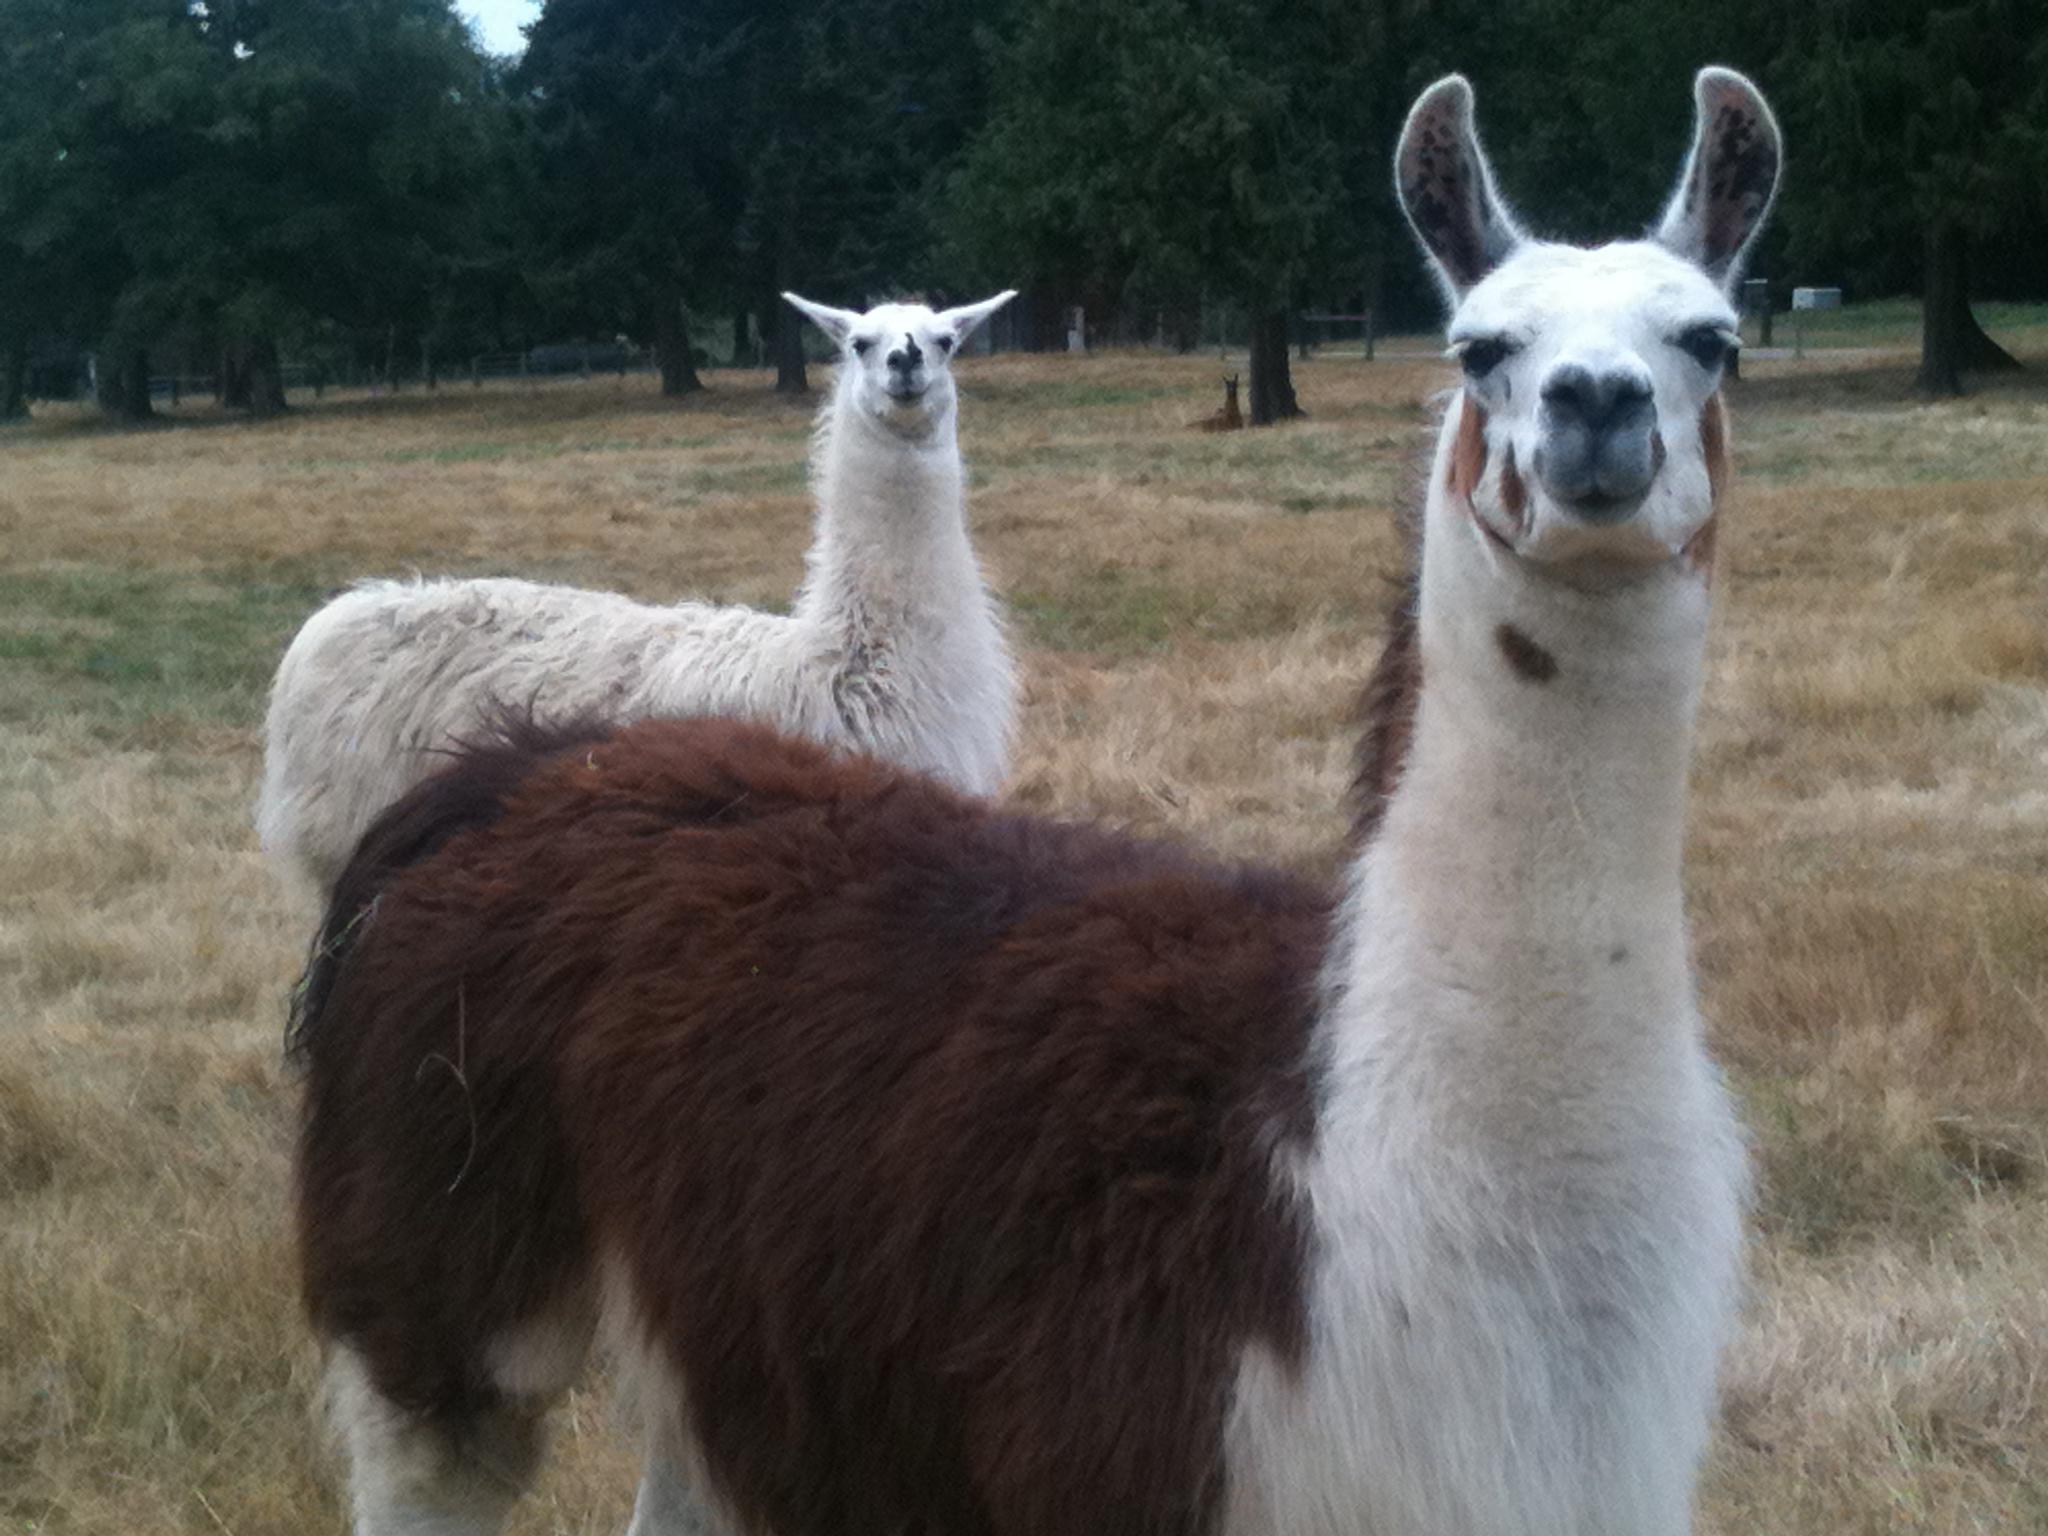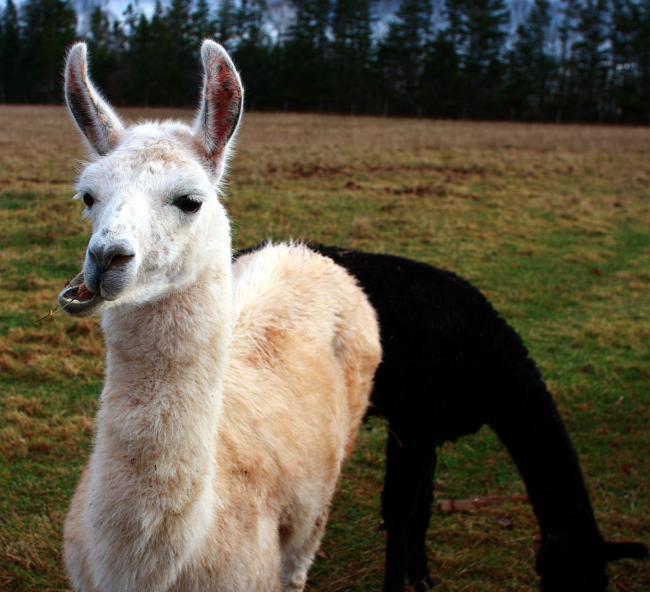The first image is the image on the left, the second image is the image on the right. Evaluate the accuracy of this statement regarding the images: "In at least one image there is a brown adult lama next to its black and white baby lama.". Is it true? Answer yes or no. No. The first image is the image on the left, the second image is the image on the right. Evaluate the accuracy of this statement regarding the images: "In one of the images, two llamas are looking at the camera.". Is it true? Answer yes or no. Yes. 